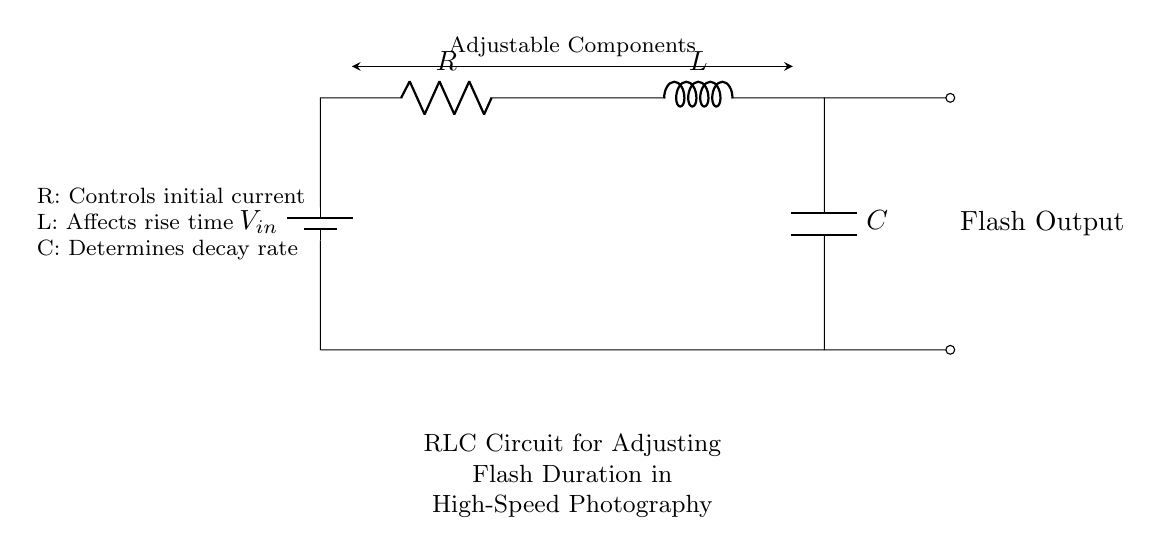What are the components in this circuit? The components are a battery, a resistor, an inductor, and a capacitor, as indicated in the circuit diagram with their labels.
Answer: battery, resistor, inductor, capacitor What does the resistor control in the circuit? The resistor controls the initial current, as explicitly stated in the diagram's accompanying text near the components.
Answer: initial current What effect does the inductor have on the circuit? The inductor affects the rise time of the current, which references the inductor's role in delaying changes in current according to its function.
Answer: rise time What is the purpose of the capacitor in this circuit? The capacitor determines the decay rate, fulfilling its function of storing and releasing energy over time, thus affecting the flash duration.
Answer: decay rate What is the circuit type? This is an RLC circuit, as it consists of a resistor, inductor, and capacitor interconnected to manage flash duration in high-speed photography.
Answer: RLC circuit How are the components connected in this circuit? The components are connected in series, starting from the battery to the resistor, then to the inductor and ending at the capacitor, completing the loop.
Answer: series What is the function of the flash output in this circuit? The flash output provides the signal for a flash, indicating the application in high-speed photography where quick bursts of light are necessary.
Answer: flash signal 